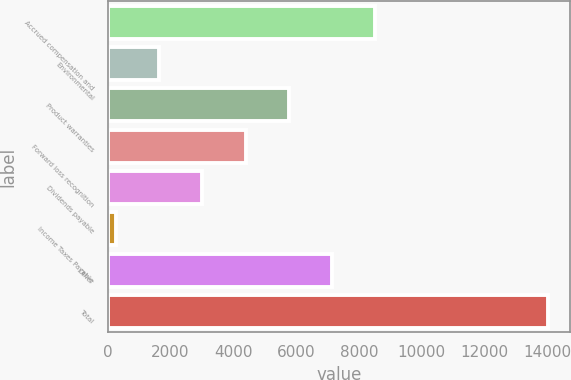Convert chart to OTSL. <chart><loc_0><loc_0><loc_500><loc_500><bar_chart><fcel>Accrued compensation and<fcel>Environmental<fcel>Product warranties<fcel>Forward loss recognition<fcel>Dividends payable<fcel>Income Taxes Payable<fcel>Other<fcel>Total<nl><fcel>8513.2<fcel>1637.2<fcel>5762.8<fcel>4387.6<fcel>3012.4<fcel>262<fcel>7138<fcel>14014<nl></chart> 